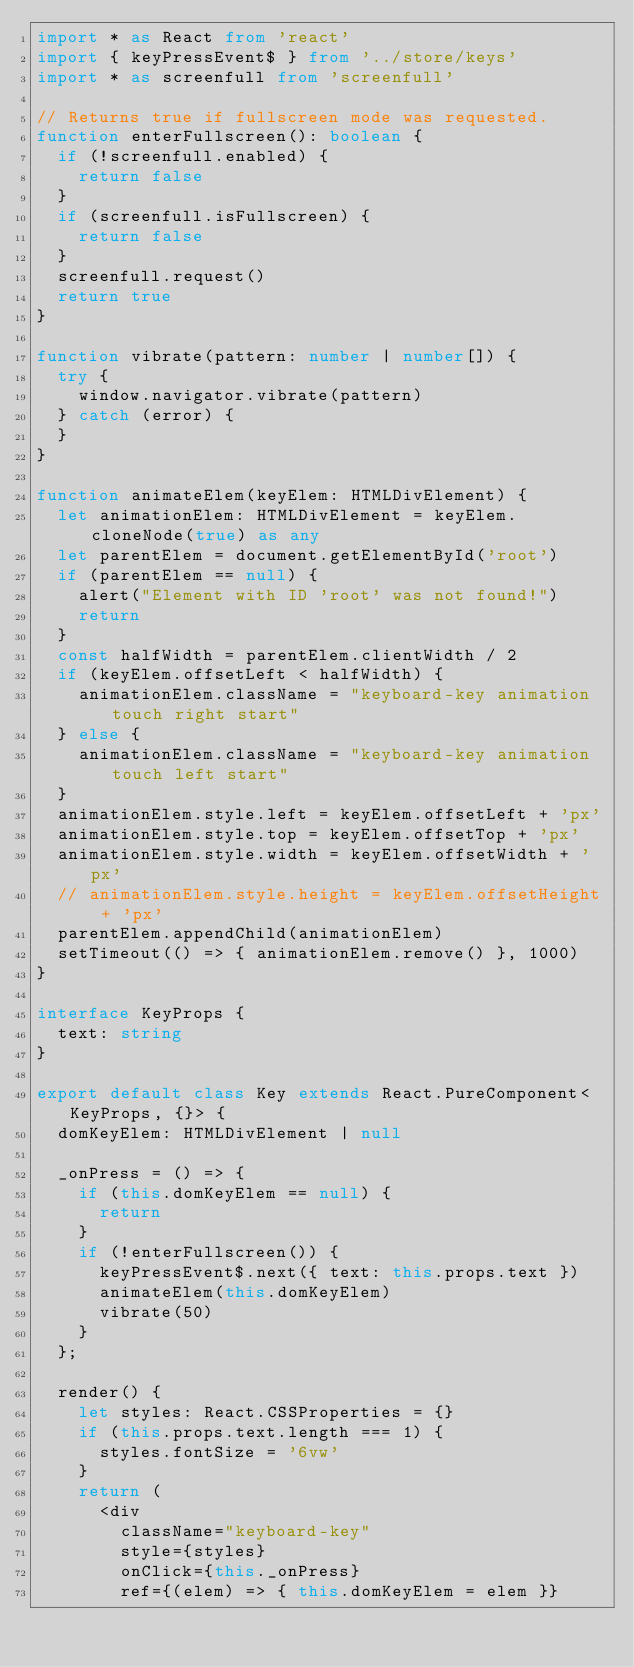Convert code to text. <code><loc_0><loc_0><loc_500><loc_500><_TypeScript_>import * as React from 'react'
import { keyPressEvent$ } from '../store/keys'
import * as screenfull from 'screenfull'

// Returns true if fullscreen mode was requested.
function enterFullscreen(): boolean {
	if (!screenfull.enabled) {
		return false
	}
	if (screenfull.isFullscreen) {
		return false
	}
	screenfull.request()
	return true
}

function vibrate(pattern: number | number[]) {
	try {
		window.navigator.vibrate(pattern)
	} catch (error) {
	}
}

function animateElem(keyElem: HTMLDivElement) {
	let animationElem: HTMLDivElement = keyElem.cloneNode(true) as any
	let parentElem = document.getElementById('root')
	if (parentElem == null) {
		alert("Element with ID 'root' was not found!")
		return
	}
	const halfWidth = parentElem.clientWidth / 2
	if (keyElem.offsetLeft < halfWidth) {
		animationElem.className = "keyboard-key animation touch right start"
	} else {
		animationElem.className = "keyboard-key animation touch left start"
	}
	animationElem.style.left = keyElem.offsetLeft + 'px'
	animationElem.style.top = keyElem.offsetTop + 'px'
	animationElem.style.width = keyElem.offsetWidth + 'px'
	// animationElem.style.height = keyElem.offsetHeight + 'px'
	parentElem.appendChild(animationElem)
	setTimeout(() => { animationElem.remove() }, 1000)
}

interface KeyProps {
	text: string
}

export default class Key extends React.PureComponent<KeyProps, {}> {
	domKeyElem: HTMLDivElement | null

	_onPress = () => {
		if (this.domKeyElem == null) {
			return
		}
		if (!enterFullscreen()) {
			keyPressEvent$.next({ text: this.props.text })
			animateElem(this.domKeyElem)
			vibrate(50)
		}
	};

	render() {
		let styles: React.CSSProperties = {}
		if (this.props.text.length === 1) {
			styles.fontSize = '6vw'
		}
		return (
			<div
				className="keyboard-key"
				style={styles}
				onClick={this._onPress}
				ref={(elem) => { this.domKeyElem = elem }}</code> 